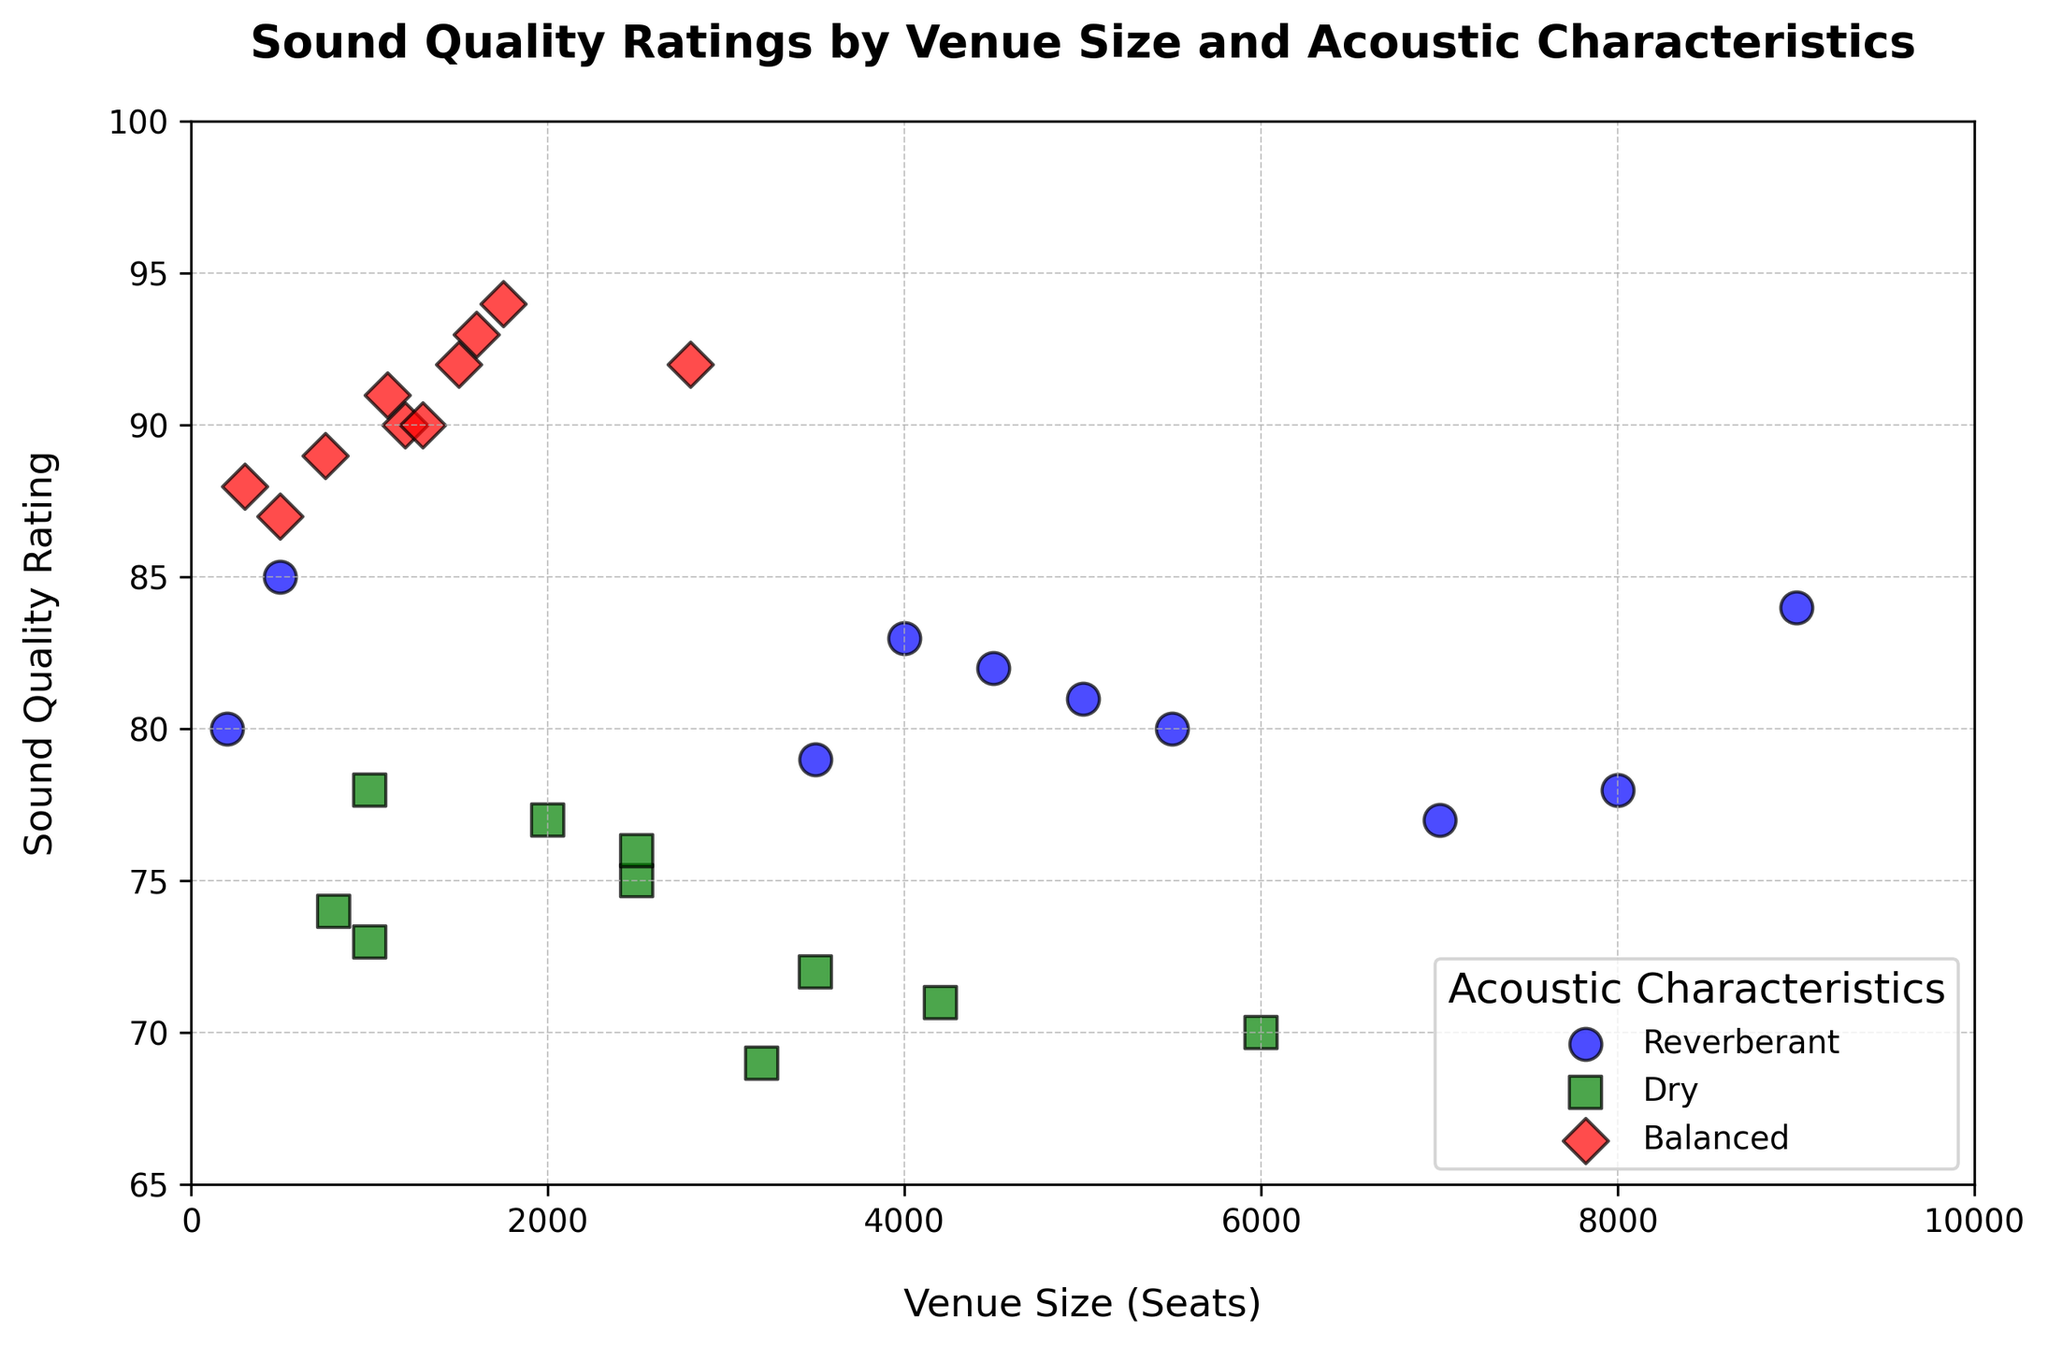What is the Sound Quality Rating for a venue with 2000 seats and Dry acoustic characteristics? Locate the point corresponding to Venue Size (2000 seats) with Dry acoustic characteristics (green square marker). The Sound Quality Rating is 77.
Answer: 77 Which venue size has the highest Sound Quality Rating and what is the rating? Identify the point with the highest position on the y-axis (Sound Quality Rating). The highest point corresponds to the venue size of 1750 seats with a rating of 94.
Answer: 1750 seats, Rating 94 How many venues with balanced acoustic characteristics have a sound quality rating above 90? Count the red diamond-shaped markers located above the y-axis value of 90. There are 5 such markers.
Answer: 5 Which acoustic characteristic has the most consistent Sound Quality Ratings, and how can you tell? Look for the group of points (color-coded by acoustic characteristics) that are closely clustered together on the y-axis. Balanced acoustic characteristics (red diamonds) are most consistently clustered around high ratings between 88 and 94.
Answer: Balanced What is the average Sound Quality Rating for venues with Reverberant acoustics? Identify the blue circle markers and determine their y-axis values: (85, 80, 79, 82, 78, 81, 83, 80, 77, 84). Sum these up to get 729 and divide by the number of points (10). 729 / 10 = 72.9
Answer: 72.9 Which acoustic characteristic has the lowest sound quality rating and what is that rating? Find the point with the lowest y-axis value. The green square marker for Dry acoustic characteristics (venue size 3200 seats) shows the lowest rating of 69.
Answer: Dry, Rating 69 For venues with more than 3000 seats, which acoustic characteristic shows the highest sound quality rating and what is the rating? Focus on points with X-values (venue size) greater than 3000. The highest y-axis value among them is the blue circle marker for the venue size 9000 seats with a rating of 84.
Answer: Reverberant, Rating 84 What is the difference in Sound Quality Ratings between the largest and smallest venues with Balanced acoustics? Identify the ratings for the largest and smallest venues (2800 seats with Rating 92 and 300 seats with Rating 88 respectively). The difference is 92 - 88 = 4.
Answer: 4 How does the sound quality rating trend differ between venues with Dry and Reverberant acoustic characteristics as the venue size increases? Compare the position and spread of green square markers (Dry) and blue circle markers (Reverberant) along the x-axis. Dry venues generally show a decreasing trend in Sound Quality Ratings, while Reverberant venues have a more varied, less consistent set of ratings with a slight increase at larger venues.
Answer: Dry shows a decreasing trend; Reverberant is varied Which size range for Balanced acoustics provides the most variable sound quality ratings? Look for the spread in y-values (Sound Quality Ratings) among red diamonds within specific venue size ranges. The size range from 300 to 1750 seats shows ratings ranging from 88 to 94, indicating variability.
Answer: 300 to 1750 seats 